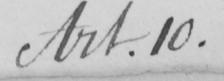What is written in this line of handwriting? Art.10 . 